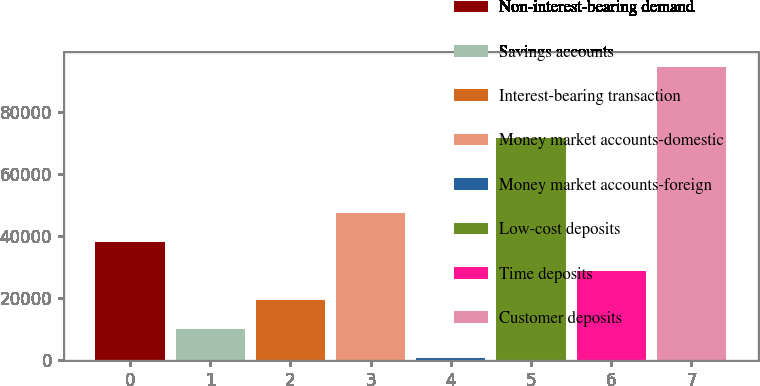Convert chart to OTSL. <chart><loc_0><loc_0><loc_500><loc_500><bar_chart><fcel>Non-interest-bearing demand<fcel>Savings accounts<fcel>Interest-bearing transaction<fcel>Money market accounts-domestic<fcel>Money market accounts-foreign<fcel>Low-cost deposits<fcel>Time deposits<fcel>Customer deposits<nl><fcel>38224.6<fcel>10038.4<fcel>19433.8<fcel>47620<fcel>643<fcel>71813<fcel>28829.2<fcel>94597<nl></chart> 